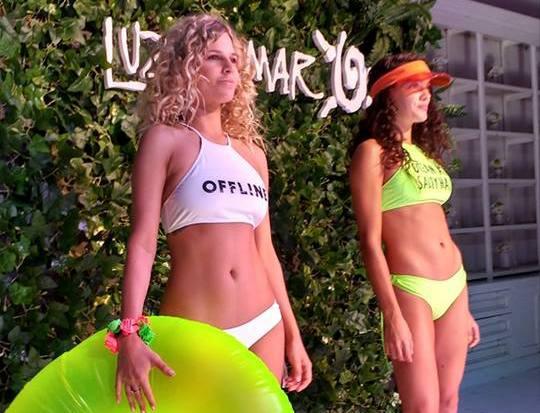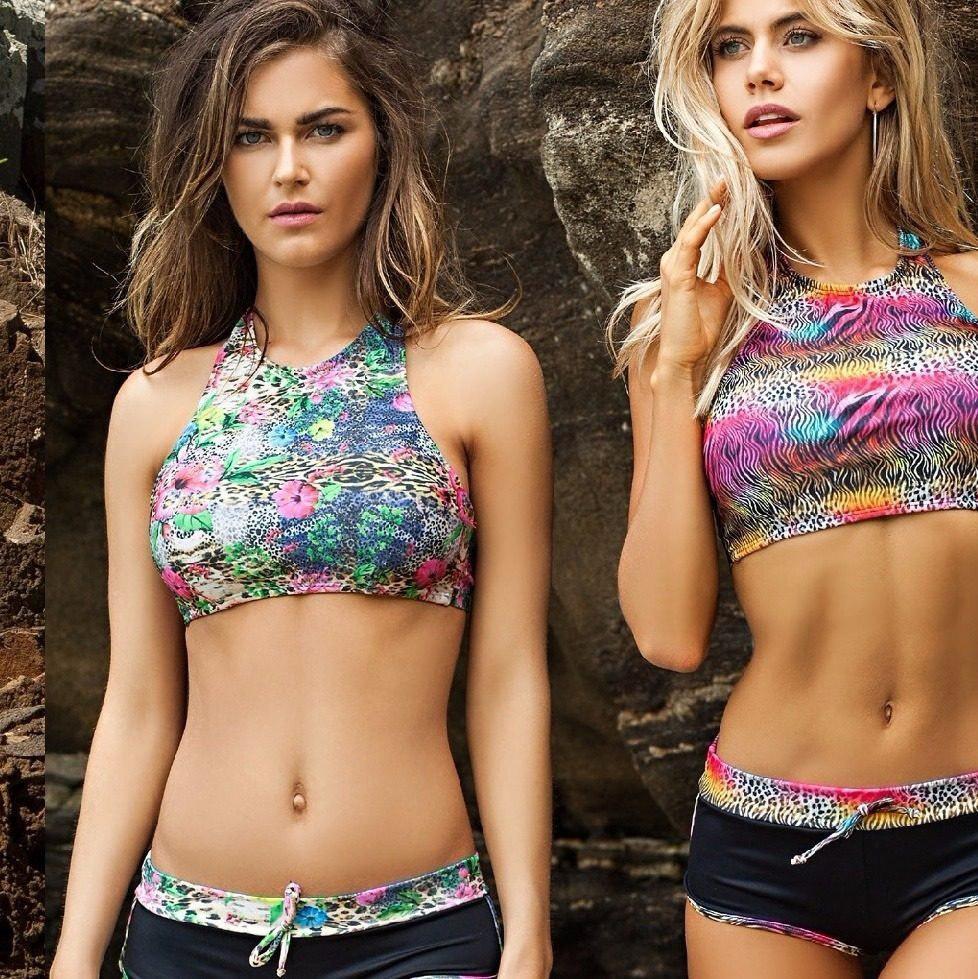The first image is the image on the left, the second image is the image on the right. Assess this claim about the two images: "Both images contain the same number of women.". Correct or not? Answer yes or no. Yes. The first image is the image on the left, the second image is the image on the right. For the images shown, is this caption "The right image shows exactly two models wearing bikinis with tops that extend over the chest and taper up to the neck." true? Answer yes or no. Yes. 